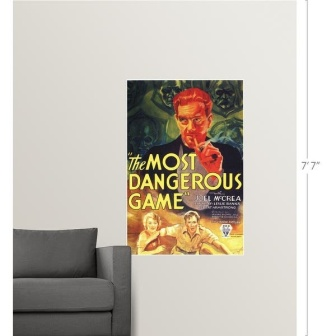What aspects of this poster might be considered iconic or representative of its era? The poster for 'The Most Dangerous Game' embodies several elements that can be considered iconic or representative of its era. First, the use of vivid and contrasting colors is typical of vintage movie posters, designed to grab attention and evoke strong emotions. The central character's exaggerated features and intense expression are stylistic choices that reflect the dramatic, larger-than-life portrayal common in early 20th-century film advertising. The bold typography, especially the title written in bright yellow letters, is characteristic of the period, meant to ensure that the movie's name is easily recognizable and memorable. Additionally, the inclusion of the actors' and director's names prominently highlights the star-centric marketing approach of classic Hollywood. Overall, the poster's composition, artistic style, and typography not only sell the movie's thrilling storyline but also encapsulate the aesthetics and marketing strategies of its time. Describe a short story inspired by this poster. Once upon a time, in a cozy apartment adorned with mementos of cinematic greatness, there hung a poster of 'The Most Dangerous Game.' The colors of the poster were so vivid and striking that it became a topic of many conversations among visitors. One stormy night, as thunder roared and lightning flashed, something extraordinary happened. The man with the red face began to move, his intense eyes scanning the room. Slowly, he stepped out of the poster and into the real world, bringing with him the essence of the thrilling universe he came from. Joel McCrea and Fay Wray's characters followed, bewildered but ready to adapt. The trio explored the apartment, turning everyday items into tools of survival and defense. Their adventure lasted through the night, blending the realms of fiction and reality until the first light of dawn broke through. As the sun rose, the characters returned to their poster, leaving behind a room rich with the energy of a story that had briefly come to life. 